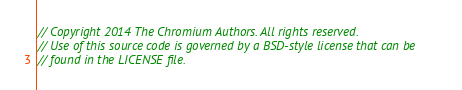<code> <loc_0><loc_0><loc_500><loc_500><_C++_>// Copyright 2014 The Chromium Authors. All rights reserved.
// Use of this source code is governed by a BSD-style license that can be
// found in the LICENSE file.
</code> 